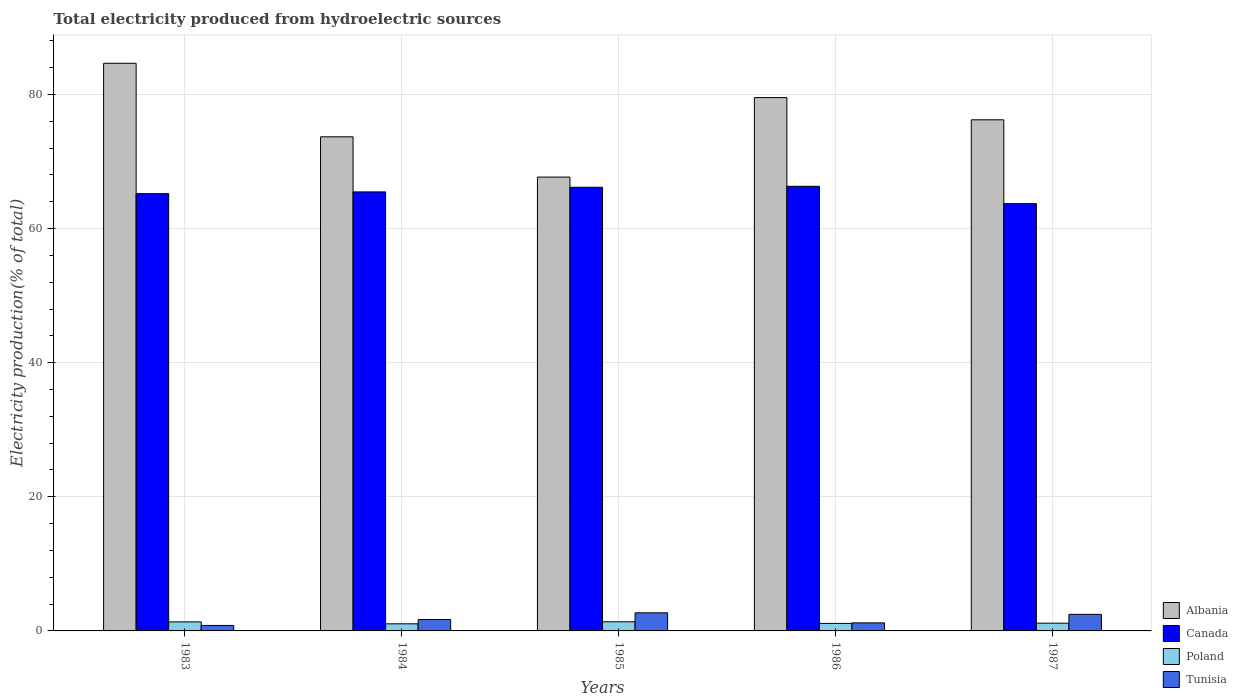How many different coloured bars are there?
Make the answer very short. 4. How many groups of bars are there?
Your answer should be compact. 5. Are the number of bars on each tick of the X-axis equal?
Your response must be concise. Yes. In how many cases, is the number of bars for a given year not equal to the number of legend labels?
Your answer should be compact. 0. What is the total electricity produced in Canada in 1983?
Provide a succinct answer. 65.21. Across all years, what is the maximum total electricity produced in Poland?
Give a very brief answer. 1.37. Across all years, what is the minimum total electricity produced in Poland?
Provide a succinct answer. 1.06. In which year was the total electricity produced in Poland maximum?
Make the answer very short. 1985. What is the total total electricity produced in Tunisia in the graph?
Your response must be concise. 8.89. What is the difference between the total electricity produced in Canada in 1984 and that in 1986?
Your answer should be very brief. -0.83. What is the difference between the total electricity produced in Poland in 1987 and the total electricity produced in Albania in 1985?
Your answer should be very brief. -66.53. What is the average total electricity produced in Canada per year?
Provide a short and direct response. 65.38. In the year 1986, what is the difference between the total electricity produced in Canada and total electricity produced in Poland?
Make the answer very short. 65.19. What is the ratio of the total electricity produced in Tunisia in 1983 to that in 1984?
Give a very brief answer. 0.48. What is the difference between the highest and the second highest total electricity produced in Poland?
Give a very brief answer. 0.02. What is the difference between the highest and the lowest total electricity produced in Poland?
Your answer should be compact. 0.31. Is the sum of the total electricity produced in Tunisia in 1983 and 1985 greater than the maximum total electricity produced in Poland across all years?
Offer a very short reply. Yes. What does the 4th bar from the right in 1984 represents?
Make the answer very short. Albania. How many years are there in the graph?
Your answer should be very brief. 5. Are the values on the major ticks of Y-axis written in scientific E-notation?
Give a very brief answer. No. Does the graph contain any zero values?
Keep it short and to the point. No. Does the graph contain grids?
Offer a terse response. Yes. How many legend labels are there?
Make the answer very short. 4. What is the title of the graph?
Offer a very short reply. Total electricity produced from hydroelectric sources. What is the label or title of the Y-axis?
Your answer should be very brief. Electricity production(% of total). What is the Electricity production(% of total) in Albania in 1983?
Give a very brief answer. 84.66. What is the Electricity production(% of total) of Canada in 1983?
Ensure brevity in your answer.  65.21. What is the Electricity production(% of total) in Poland in 1983?
Offer a terse response. 1.35. What is the Electricity production(% of total) in Tunisia in 1983?
Your answer should be compact. 0.82. What is the Electricity production(% of total) of Albania in 1984?
Provide a succinct answer. 73.69. What is the Electricity production(% of total) of Canada in 1984?
Provide a succinct answer. 65.47. What is the Electricity production(% of total) of Poland in 1984?
Keep it short and to the point. 1.06. What is the Electricity production(% of total) in Tunisia in 1984?
Your answer should be compact. 1.7. What is the Electricity production(% of total) of Albania in 1985?
Your answer should be very brief. 67.68. What is the Electricity production(% of total) of Canada in 1985?
Make the answer very short. 66.17. What is the Electricity production(% of total) in Poland in 1985?
Offer a terse response. 1.37. What is the Electricity production(% of total) of Tunisia in 1985?
Offer a terse response. 2.7. What is the Electricity production(% of total) of Albania in 1986?
Offer a terse response. 79.53. What is the Electricity production(% of total) of Canada in 1986?
Provide a succinct answer. 66.31. What is the Electricity production(% of total) in Poland in 1986?
Provide a succinct answer. 1.12. What is the Electricity production(% of total) of Tunisia in 1986?
Make the answer very short. 1.2. What is the Electricity production(% of total) of Albania in 1987?
Your response must be concise. 76.22. What is the Electricity production(% of total) of Canada in 1987?
Keep it short and to the point. 63.72. What is the Electricity production(% of total) of Poland in 1987?
Ensure brevity in your answer.  1.16. What is the Electricity production(% of total) of Tunisia in 1987?
Ensure brevity in your answer.  2.47. Across all years, what is the maximum Electricity production(% of total) in Albania?
Offer a very short reply. 84.66. Across all years, what is the maximum Electricity production(% of total) of Canada?
Provide a short and direct response. 66.31. Across all years, what is the maximum Electricity production(% of total) in Poland?
Make the answer very short. 1.37. Across all years, what is the maximum Electricity production(% of total) in Tunisia?
Offer a very short reply. 2.7. Across all years, what is the minimum Electricity production(% of total) in Albania?
Your answer should be compact. 67.68. Across all years, what is the minimum Electricity production(% of total) in Canada?
Your answer should be very brief. 63.72. Across all years, what is the minimum Electricity production(% of total) in Poland?
Ensure brevity in your answer.  1.06. Across all years, what is the minimum Electricity production(% of total) of Tunisia?
Your response must be concise. 0.82. What is the total Electricity production(% of total) in Albania in the graph?
Make the answer very short. 381.78. What is the total Electricity production(% of total) of Canada in the graph?
Give a very brief answer. 326.88. What is the total Electricity production(% of total) of Poland in the graph?
Provide a succinct answer. 6.05. What is the total Electricity production(% of total) of Tunisia in the graph?
Your answer should be compact. 8.89. What is the difference between the Electricity production(% of total) in Albania in 1983 and that in 1984?
Provide a short and direct response. 10.97. What is the difference between the Electricity production(% of total) of Canada in 1983 and that in 1984?
Provide a short and direct response. -0.26. What is the difference between the Electricity production(% of total) in Poland in 1983 and that in 1984?
Provide a succinct answer. 0.29. What is the difference between the Electricity production(% of total) in Tunisia in 1983 and that in 1984?
Keep it short and to the point. -0.88. What is the difference between the Electricity production(% of total) of Albania in 1983 and that in 1985?
Your answer should be very brief. 16.97. What is the difference between the Electricity production(% of total) in Canada in 1983 and that in 1985?
Give a very brief answer. -0.96. What is the difference between the Electricity production(% of total) of Poland in 1983 and that in 1985?
Your answer should be compact. -0.02. What is the difference between the Electricity production(% of total) of Tunisia in 1983 and that in 1985?
Your answer should be very brief. -1.88. What is the difference between the Electricity production(% of total) of Albania in 1983 and that in 1986?
Your response must be concise. 5.12. What is the difference between the Electricity production(% of total) of Canada in 1983 and that in 1986?
Offer a very short reply. -1.1. What is the difference between the Electricity production(% of total) of Poland in 1983 and that in 1986?
Offer a very short reply. 0.23. What is the difference between the Electricity production(% of total) of Tunisia in 1983 and that in 1986?
Give a very brief answer. -0.39. What is the difference between the Electricity production(% of total) of Albania in 1983 and that in 1987?
Keep it short and to the point. 8.43. What is the difference between the Electricity production(% of total) of Canada in 1983 and that in 1987?
Keep it short and to the point. 1.49. What is the difference between the Electricity production(% of total) in Poland in 1983 and that in 1987?
Provide a short and direct response. 0.19. What is the difference between the Electricity production(% of total) in Tunisia in 1983 and that in 1987?
Your answer should be compact. -1.65. What is the difference between the Electricity production(% of total) in Albania in 1984 and that in 1985?
Provide a succinct answer. 6. What is the difference between the Electricity production(% of total) in Canada in 1984 and that in 1985?
Provide a succinct answer. -0.69. What is the difference between the Electricity production(% of total) in Poland in 1984 and that in 1985?
Keep it short and to the point. -0.31. What is the difference between the Electricity production(% of total) in Tunisia in 1984 and that in 1985?
Your answer should be compact. -1. What is the difference between the Electricity production(% of total) in Albania in 1984 and that in 1986?
Provide a short and direct response. -5.85. What is the difference between the Electricity production(% of total) of Canada in 1984 and that in 1986?
Keep it short and to the point. -0.83. What is the difference between the Electricity production(% of total) of Poland in 1984 and that in 1986?
Your answer should be very brief. -0.06. What is the difference between the Electricity production(% of total) of Tunisia in 1984 and that in 1986?
Give a very brief answer. 0.5. What is the difference between the Electricity production(% of total) in Albania in 1984 and that in 1987?
Provide a succinct answer. -2.53. What is the difference between the Electricity production(% of total) of Canada in 1984 and that in 1987?
Your answer should be compact. 1.75. What is the difference between the Electricity production(% of total) in Poland in 1984 and that in 1987?
Ensure brevity in your answer.  -0.1. What is the difference between the Electricity production(% of total) in Tunisia in 1984 and that in 1987?
Provide a short and direct response. -0.77. What is the difference between the Electricity production(% of total) in Albania in 1985 and that in 1986?
Provide a short and direct response. -11.85. What is the difference between the Electricity production(% of total) of Canada in 1985 and that in 1986?
Offer a terse response. -0.14. What is the difference between the Electricity production(% of total) of Poland in 1985 and that in 1986?
Keep it short and to the point. 0.24. What is the difference between the Electricity production(% of total) in Tunisia in 1985 and that in 1986?
Your answer should be very brief. 1.5. What is the difference between the Electricity production(% of total) in Albania in 1985 and that in 1987?
Provide a succinct answer. -8.54. What is the difference between the Electricity production(% of total) of Canada in 1985 and that in 1987?
Provide a short and direct response. 2.45. What is the difference between the Electricity production(% of total) of Poland in 1985 and that in 1987?
Your answer should be very brief. 0.21. What is the difference between the Electricity production(% of total) of Tunisia in 1985 and that in 1987?
Offer a very short reply. 0.23. What is the difference between the Electricity production(% of total) in Albania in 1986 and that in 1987?
Your answer should be compact. 3.31. What is the difference between the Electricity production(% of total) of Canada in 1986 and that in 1987?
Offer a terse response. 2.59. What is the difference between the Electricity production(% of total) of Poland in 1986 and that in 1987?
Ensure brevity in your answer.  -0.04. What is the difference between the Electricity production(% of total) in Tunisia in 1986 and that in 1987?
Offer a terse response. -1.27. What is the difference between the Electricity production(% of total) in Albania in 1983 and the Electricity production(% of total) in Canada in 1984?
Ensure brevity in your answer.  19.18. What is the difference between the Electricity production(% of total) in Albania in 1983 and the Electricity production(% of total) in Poland in 1984?
Ensure brevity in your answer.  83.6. What is the difference between the Electricity production(% of total) of Albania in 1983 and the Electricity production(% of total) of Tunisia in 1984?
Give a very brief answer. 82.96. What is the difference between the Electricity production(% of total) in Canada in 1983 and the Electricity production(% of total) in Poland in 1984?
Offer a terse response. 64.15. What is the difference between the Electricity production(% of total) of Canada in 1983 and the Electricity production(% of total) of Tunisia in 1984?
Provide a succinct answer. 63.51. What is the difference between the Electricity production(% of total) of Poland in 1983 and the Electricity production(% of total) of Tunisia in 1984?
Provide a succinct answer. -0.35. What is the difference between the Electricity production(% of total) in Albania in 1983 and the Electricity production(% of total) in Canada in 1985?
Offer a terse response. 18.49. What is the difference between the Electricity production(% of total) of Albania in 1983 and the Electricity production(% of total) of Poland in 1985?
Make the answer very short. 83.29. What is the difference between the Electricity production(% of total) of Albania in 1983 and the Electricity production(% of total) of Tunisia in 1985?
Your response must be concise. 81.96. What is the difference between the Electricity production(% of total) of Canada in 1983 and the Electricity production(% of total) of Poland in 1985?
Ensure brevity in your answer.  63.85. What is the difference between the Electricity production(% of total) in Canada in 1983 and the Electricity production(% of total) in Tunisia in 1985?
Your response must be concise. 62.51. What is the difference between the Electricity production(% of total) of Poland in 1983 and the Electricity production(% of total) of Tunisia in 1985?
Ensure brevity in your answer.  -1.35. What is the difference between the Electricity production(% of total) in Albania in 1983 and the Electricity production(% of total) in Canada in 1986?
Give a very brief answer. 18.35. What is the difference between the Electricity production(% of total) in Albania in 1983 and the Electricity production(% of total) in Poland in 1986?
Offer a terse response. 83.53. What is the difference between the Electricity production(% of total) of Albania in 1983 and the Electricity production(% of total) of Tunisia in 1986?
Your answer should be compact. 83.45. What is the difference between the Electricity production(% of total) of Canada in 1983 and the Electricity production(% of total) of Poland in 1986?
Your answer should be very brief. 64.09. What is the difference between the Electricity production(% of total) in Canada in 1983 and the Electricity production(% of total) in Tunisia in 1986?
Provide a short and direct response. 64.01. What is the difference between the Electricity production(% of total) in Poland in 1983 and the Electricity production(% of total) in Tunisia in 1986?
Offer a terse response. 0.15. What is the difference between the Electricity production(% of total) of Albania in 1983 and the Electricity production(% of total) of Canada in 1987?
Your answer should be very brief. 20.94. What is the difference between the Electricity production(% of total) of Albania in 1983 and the Electricity production(% of total) of Poland in 1987?
Your answer should be very brief. 83.5. What is the difference between the Electricity production(% of total) in Albania in 1983 and the Electricity production(% of total) in Tunisia in 1987?
Give a very brief answer. 82.19. What is the difference between the Electricity production(% of total) in Canada in 1983 and the Electricity production(% of total) in Poland in 1987?
Provide a short and direct response. 64.05. What is the difference between the Electricity production(% of total) of Canada in 1983 and the Electricity production(% of total) of Tunisia in 1987?
Provide a succinct answer. 62.74. What is the difference between the Electricity production(% of total) in Poland in 1983 and the Electricity production(% of total) in Tunisia in 1987?
Make the answer very short. -1.12. What is the difference between the Electricity production(% of total) of Albania in 1984 and the Electricity production(% of total) of Canada in 1985?
Provide a short and direct response. 7.52. What is the difference between the Electricity production(% of total) of Albania in 1984 and the Electricity production(% of total) of Poland in 1985?
Offer a very short reply. 72.32. What is the difference between the Electricity production(% of total) in Albania in 1984 and the Electricity production(% of total) in Tunisia in 1985?
Your answer should be very brief. 70.99. What is the difference between the Electricity production(% of total) in Canada in 1984 and the Electricity production(% of total) in Poland in 1985?
Your answer should be very brief. 64.11. What is the difference between the Electricity production(% of total) in Canada in 1984 and the Electricity production(% of total) in Tunisia in 1985?
Provide a succinct answer. 62.77. What is the difference between the Electricity production(% of total) in Poland in 1984 and the Electricity production(% of total) in Tunisia in 1985?
Ensure brevity in your answer.  -1.64. What is the difference between the Electricity production(% of total) of Albania in 1984 and the Electricity production(% of total) of Canada in 1986?
Your answer should be compact. 7.38. What is the difference between the Electricity production(% of total) in Albania in 1984 and the Electricity production(% of total) in Poland in 1986?
Your answer should be very brief. 72.57. What is the difference between the Electricity production(% of total) in Albania in 1984 and the Electricity production(% of total) in Tunisia in 1986?
Provide a succinct answer. 72.49. What is the difference between the Electricity production(% of total) of Canada in 1984 and the Electricity production(% of total) of Poland in 1986?
Make the answer very short. 64.35. What is the difference between the Electricity production(% of total) of Canada in 1984 and the Electricity production(% of total) of Tunisia in 1986?
Make the answer very short. 64.27. What is the difference between the Electricity production(% of total) of Poland in 1984 and the Electricity production(% of total) of Tunisia in 1986?
Provide a short and direct response. -0.14. What is the difference between the Electricity production(% of total) of Albania in 1984 and the Electricity production(% of total) of Canada in 1987?
Provide a succinct answer. 9.97. What is the difference between the Electricity production(% of total) in Albania in 1984 and the Electricity production(% of total) in Poland in 1987?
Ensure brevity in your answer.  72.53. What is the difference between the Electricity production(% of total) of Albania in 1984 and the Electricity production(% of total) of Tunisia in 1987?
Offer a very short reply. 71.22. What is the difference between the Electricity production(% of total) in Canada in 1984 and the Electricity production(% of total) in Poland in 1987?
Your response must be concise. 64.31. What is the difference between the Electricity production(% of total) of Canada in 1984 and the Electricity production(% of total) of Tunisia in 1987?
Offer a very short reply. 63. What is the difference between the Electricity production(% of total) of Poland in 1984 and the Electricity production(% of total) of Tunisia in 1987?
Provide a succinct answer. -1.41. What is the difference between the Electricity production(% of total) in Albania in 1985 and the Electricity production(% of total) in Canada in 1986?
Provide a short and direct response. 1.38. What is the difference between the Electricity production(% of total) of Albania in 1985 and the Electricity production(% of total) of Poland in 1986?
Ensure brevity in your answer.  66.56. What is the difference between the Electricity production(% of total) of Albania in 1985 and the Electricity production(% of total) of Tunisia in 1986?
Offer a terse response. 66.48. What is the difference between the Electricity production(% of total) in Canada in 1985 and the Electricity production(% of total) in Poland in 1986?
Keep it short and to the point. 65.04. What is the difference between the Electricity production(% of total) in Canada in 1985 and the Electricity production(% of total) in Tunisia in 1986?
Make the answer very short. 64.97. What is the difference between the Electricity production(% of total) in Poland in 1985 and the Electricity production(% of total) in Tunisia in 1986?
Give a very brief answer. 0.16. What is the difference between the Electricity production(% of total) of Albania in 1985 and the Electricity production(% of total) of Canada in 1987?
Offer a terse response. 3.96. What is the difference between the Electricity production(% of total) in Albania in 1985 and the Electricity production(% of total) in Poland in 1987?
Give a very brief answer. 66.53. What is the difference between the Electricity production(% of total) in Albania in 1985 and the Electricity production(% of total) in Tunisia in 1987?
Provide a short and direct response. 65.21. What is the difference between the Electricity production(% of total) of Canada in 1985 and the Electricity production(% of total) of Poland in 1987?
Your answer should be compact. 65.01. What is the difference between the Electricity production(% of total) in Canada in 1985 and the Electricity production(% of total) in Tunisia in 1987?
Provide a short and direct response. 63.7. What is the difference between the Electricity production(% of total) of Poland in 1985 and the Electricity production(% of total) of Tunisia in 1987?
Provide a short and direct response. -1.11. What is the difference between the Electricity production(% of total) in Albania in 1986 and the Electricity production(% of total) in Canada in 1987?
Offer a very short reply. 15.81. What is the difference between the Electricity production(% of total) of Albania in 1986 and the Electricity production(% of total) of Poland in 1987?
Offer a very short reply. 78.38. What is the difference between the Electricity production(% of total) of Albania in 1986 and the Electricity production(% of total) of Tunisia in 1987?
Your answer should be compact. 77.06. What is the difference between the Electricity production(% of total) of Canada in 1986 and the Electricity production(% of total) of Poland in 1987?
Offer a very short reply. 65.15. What is the difference between the Electricity production(% of total) in Canada in 1986 and the Electricity production(% of total) in Tunisia in 1987?
Ensure brevity in your answer.  63.84. What is the difference between the Electricity production(% of total) of Poland in 1986 and the Electricity production(% of total) of Tunisia in 1987?
Your response must be concise. -1.35. What is the average Electricity production(% of total) in Albania per year?
Make the answer very short. 76.36. What is the average Electricity production(% of total) in Canada per year?
Offer a very short reply. 65.38. What is the average Electricity production(% of total) in Poland per year?
Your answer should be compact. 1.21. What is the average Electricity production(% of total) of Tunisia per year?
Provide a short and direct response. 1.78. In the year 1983, what is the difference between the Electricity production(% of total) of Albania and Electricity production(% of total) of Canada?
Your answer should be very brief. 19.44. In the year 1983, what is the difference between the Electricity production(% of total) in Albania and Electricity production(% of total) in Poland?
Provide a short and direct response. 83.31. In the year 1983, what is the difference between the Electricity production(% of total) of Albania and Electricity production(% of total) of Tunisia?
Provide a succinct answer. 83.84. In the year 1983, what is the difference between the Electricity production(% of total) in Canada and Electricity production(% of total) in Poland?
Ensure brevity in your answer.  63.86. In the year 1983, what is the difference between the Electricity production(% of total) in Canada and Electricity production(% of total) in Tunisia?
Provide a short and direct response. 64.39. In the year 1983, what is the difference between the Electricity production(% of total) in Poland and Electricity production(% of total) in Tunisia?
Offer a very short reply. 0.53. In the year 1984, what is the difference between the Electricity production(% of total) of Albania and Electricity production(% of total) of Canada?
Provide a short and direct response. 8.22. In the year 1984, what is the difference between the Electricity production(% of total) in Albania and Electricity production(% of total) in Poland?
Provide a short and direct response. 72.63. In the year 1984, what is the difference between the Electricity production(% of total) in Albania and Electricity production(% of total) in Tunisia?
Your answer should be very brief. 71.99. In the year 1984, what is the difference between the Electricity production(% of total) of Canada and Electricity production(% of total) of Poland?
Give a very brief answer. 64.41. In the year 1984, what is the difference between the Electricity production(% of total) of Canada and Electricity production(% of total) of Tunisia?
Offer a terse response. 63.77. In the year 1984, what is the difference between the Electricity production(% of total) in Poland and Electricity production(% of total) in Tunisia?
Provide a short and direct response. -0.64. In the year 1985, what is the difference between the Electricity production(% of total) of Albania and Electricity production(% of total) of Canada?
Your answer should be very brief. 1.52. In the year 1985, what is the difference between the Electricity production(% of total) in Albania and Electricity production(% of total) in Poland?
Your answer should be compact. 66.32. In the year 1985, what is the difference between the Electricity production(% of total) of Albania and Electricity production(% of total) of Tunisia?
Offer a very short reply. 64.98. In the year 1985, what is the difference between the Electricity production(% of total) of Canada and Electricity production(% of total) of Poland?
Offer a very short reply. 64.8. In the year 1985, what is the difference between the Electricity production(% of total) of Canada and Electricity production(% of total) of Tunisia?
Make the answer very short. 63.47. In the year 1985, what is the difference between the Electricity production(% of total) of Poland and Electricity production(% of total) of Tunisia?
Your response must be concise. -1.33. In the year 1986, what is the difference between the Electricity production(% of total) in Albania and Electricity production(% of total) in Canada?
Ensure brevity in your answer.  13.23. In the year 1986, what is the difference between the Electricity production(% of total) in Albania and Electricity production(% of total) in Poland?
Give a very brief answer. 78.41. In the year 1986, what is the difference between the Electricity production(% of total) in Albania and Electricity production(% of total) in Tunisia?
Offer a very short reply. 78.33. In the year 1986, what is the difference between the Electricity production(% of total) of Canada and Electricity production(% of total) of Poland?
Your response must be concise. 65.19. In the year 1986, what is the difference between the Electricity production(% of total) in Canada and Electricity production(% of total) in Tunisia?
Provide a succinct answer. 65.11. In the year 1986, what is the difference between the Electricity production(% of total) of Poland and Electricity production(% of total) of Tunisia?
Provide a succinct answer. -0.08. In the year 1987, what is the difference between the Electricity production(% of total) in Albania and Electricity production(% of total) in Canada?
Provide a succinct answer. 12.5. In the year 1987, what is the difference between the Electricity production(% of total) of Albania and Electricity production(% of total) of Poland?
Provide a short and direct response. 75.06. In the year 1987, what is the difference between the Electricity production(% of total) in Albania and Electricity production(% of total) in Tunisia?
Offer a very short reply. 73.75. In the year 1987, what is the difference between the Electricity production(% of total) of Canada and Electricity production(% of total) of Poland?
Your answer should be very brief. 62.56. In the year 1987, what is the difference between the Electricity production(% of total) of Canada and Electricity production(% of total) of Tunisia?
Keep it short and to the point. 61.25. In the year 1987, what is the difference between the Electricity production(% of total) of Poland and Electricity production(% of total) of Tunisia?
Your response must be concise. -1.31. What is the ratio of the Electricity production(% of total) of Albania in 1983 to that in 1984?
Your answer should be compact. 1.15. What is the ratio of the Electricity production(% of total) in Canada in 1983 to that in 1984?
Ensure brevity in your answer.  1. What is the ratio of the Electricity production(% of total) in Poland in 1983 to that in 1984?
Make the answer very short. 1.27. What is the ratio of the Electricity production(% of total) in Tunisia in 1983 to that in 1984?
Ensure brevity in your answer.  0.48. What is the ratio of the Electricity production(% of total) in Albania in 1983 to that in 1985?
Offer a terse response. 1.25. What is the ratio of the Electricity production(% of total) of Canada in 1983 to that in 1985?
Keep it short and to the point. 0.99. What is the ratio of the Electricity production(% of total) in Poland in 1983 to that in 1985?
Keep it short and to the point. 0.99. What is the ratio of the Electricity production(% of total) in Tunisia in 1983 to that in 1985?
Your answer should be compact. 0.3. What is the ratio of the Electricity production(% of total) in Albania in 1983 to that in 1986?
Offer a terse response. 1.06. What is the ratio of the Electricity production(% of total) of Canada in 1983 to that in 1986?
Provide a short and direct response. 0.98. What is the ratio of the Electricity production(% of total) in Poland in 1983 to that in 1986?
Offer a very short reply. 1.2. What is the ratio of the Electricity production(% of total) of Tunisia in 1983 to that in 1986?
Ensure brevity in your answer.  0.68. What is the ratio of the Electricity production(% of total) of Albania in 1983 to that in 1987?
Your response must be concise. 1.11. What is the ratio of the Electricity production(% of total) of Canada in 1983 to that in 1987?
Keep it short and to the point. 1.02. What is the ratio of the Electricity production(% of total) of Poland in 1983 to that in 1987?
Make the answer very short. 1.16. What is the ratio of the Electricity production(% of total) in Tunisia in 1983 to that in 1987?
Offer a terse response. 0.33. What is the ratio of the Electricity production(% of total) of Albania in 1984 to that in 1985?
Your answer should be compact. 1.09. What is the ratio of the Electricity production(% of total) of Poland in 1984 to that in 1985?
Your response must be concise. 0.78. What is the ratio of the Electricity production(% of total) of Tunisia in 1984 to that in 1985?
Keep it short and to the point. 0.63. What is the ratio of the Electricity production(% of total) of Albania in 1984 to that in 1986?
Your answer should be compact. 0.93. What is the ratio of the Electricity production(% of total) in Canada in 1984 to that in 1986?
Ensure brevity in your answer.  0.99. What is the ratio of the Electricity production(% of total) of Poland in 1984 to that in 1986?
Make the answer very short. 0.94. What is the ratio of the Electricity production(% of total) of Tunisia in 1984 to that in 1986?
Your response must be concise. 1.42. What is the ratio of the Electricity production(% of total) of Albania in 1984 to that in 1987?
Provide a short and direct response. 0.97. What is the ratio of the Electricity production(% of total) in Canada in 1984 to that in 1987?
Ensure brevity in your answer.  1.03. What is the ratio of the Electricity production(% of total) of Poland in 1984 to that in 1987?
Make the answer very short. 0.92. What is the ratio of the Electricity production(% of total) of Tunisia in 1984 to that in 1987?
Your response must be concise. 0.69. What is the ratio of the Electricity production(% of total) in Albania in 1985 to that in 1986?
Offer a very short reply. 0.85. What is the ratio of the Electricity production(% of total) in Canada in 1985 to that in 1986?
Ensure brevity in your answer.  1. What is the ratio of the Electricity production(% of total) in Poland in 1985 to that in 1986?
Provide a short and direct response. 1.22. What is the ratio of the Electricity production(% of total) of Tunisia in 1985 to that in 1986?
Your answer should be compact. 2.25. What is the ratio of the Electricity production(% of total) of Albania in 1985 to that in 1987?
Offer a very short reply. 0.89. What is the ratio of the Electricity production(% of total) in Canada in 1985 to that in 1987?
Give a very brief answer. 1.04. What is the ratio of the Electricity production(% of total) of Poland in 1985 to that in 1987?
Provide a succinct answer. 1.18. What is the ratio of the Electricity production(% of total) in Tunisia in 1985 to that in 1987?
Your answer should be very brief. 1.09. What is the ratio of the Electricity production(% of total) in Albania in 1986 to that in 1987?
Make the answer very short. 1.04. What is the ratio of the Electricity production(% of total) in Canada in 1986 to that in 1987?
Keep it short and to the point. 1.04. What is the ratio of the Electricity production(% of total) of Poland in 1986 to that in 1987?
Make the answer very short. 0.97. What is the ratio of the Electricity production(% of total) in Tunisia in 1986 to that in 1987?
Give a very brief answer. 0.49. What is the difference between the highest and the second highest Electricity production(% of total) in Albania?
Give a very brief answer. 5.12. What is the difference between the highest and the second highest Electricity production(% of total) of Canada?
Provide a succinct answer. 0.14. What is the difference between the highest and the second highest Electricity production(% of total) in Poland?
Make the answer very short. 0.02. What is the difference between the highest and the second highest Electricity production(% of total) of Tunisia?
Give a very brief answer. 0.23. What is the difference between the highest and the lowest Electricity production(% of total) in Albania?
Your answer should be very brief. 16.97. What is the difference between the highest and the lowest Electricity production(% of total) in Canada?
Provide a short and direct response. 2.59. What is the difference between the highest and the lowest Electricity production(% of total) of Poland?
Your answer should be compact. 0.31. What is the difference between the highest and the lowest Electricity production(% of total) of Tunisia?
Your answer should be very brief. 1.88. 